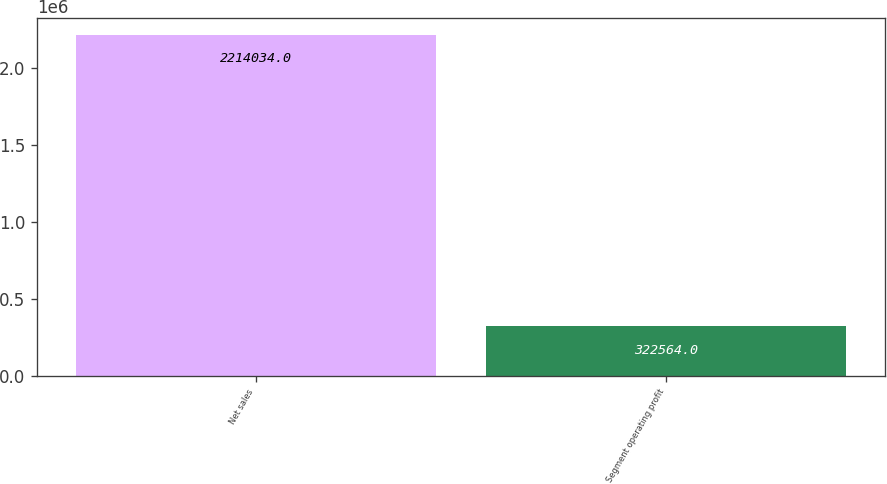Convert chart. <chart><loc_0><loc_0><loc_500><loc_500><bar_chart><fcel>Net sales<fcel>Segment operating profit<nl><fcel>2.21403e+06<fcel>322564<nl></chart> 